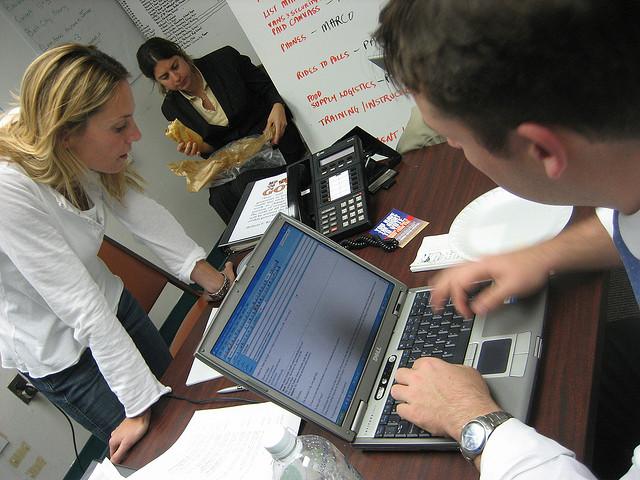How many people have watches?
Short answer required. 2. Is the woman hungry?
Answer briefly. Yes. Is anyone eating?
Give a very brief answer. Yes. 